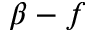Convert formula to latex. <formula><loc_0><loc_0><loc_500><loc_500>\beta - f</formula> 